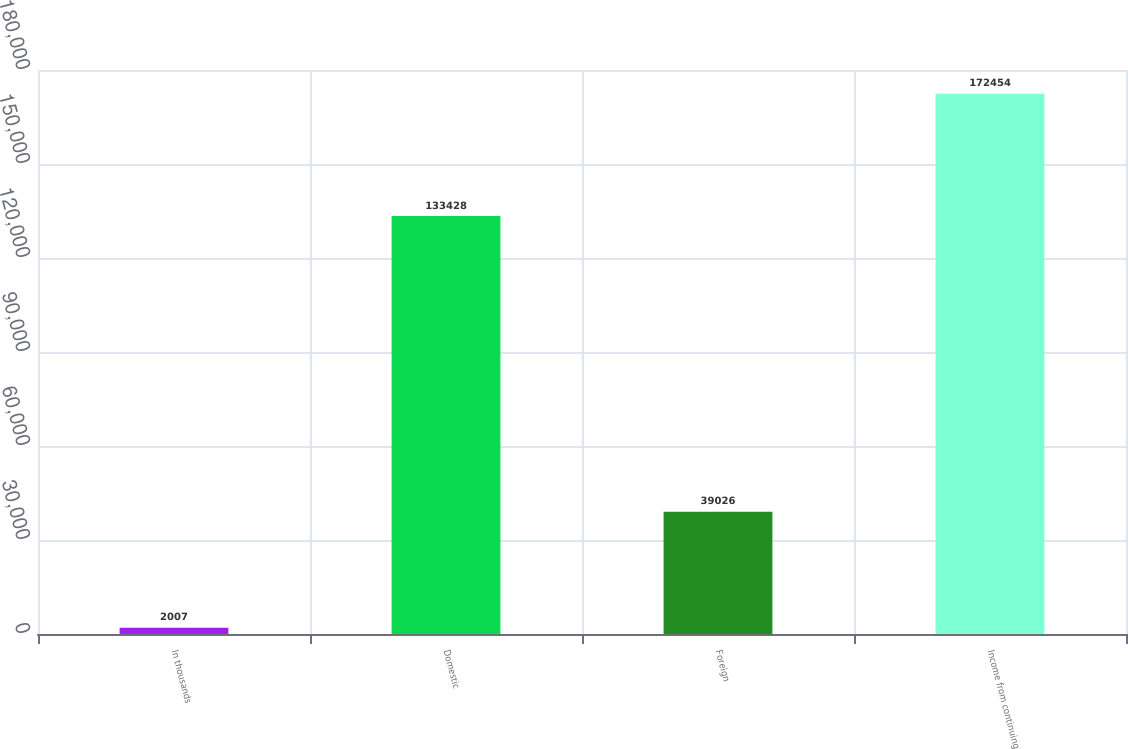Convert chart to OTSL. <chart><loc_0><loc_0><loc_500><loc_500><bar_chart><fcel>In thousands<fcel>Domestic<fcel>Foreign<fcel>Income from continuing<nl><fcel>2007<fcel>133428<fcel>39026<fcel>172454<nl></chart> 